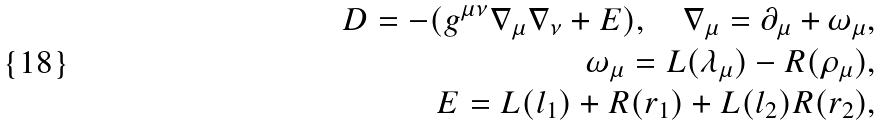Convert formula to latex. <formula><loc_0><loc_0><loc_500><loc_500>D = - ( g ^ { \mu \nu } \nabla _ { \mu } \nabla _ { \nu } + E ) , \quad \nabla _ { \mu } = \partial _ { \mu } + \omega _ { \mu } , \\ \omega _ { \mu } = L ( \lambda _ { \mu } ) - R ( \rho _ { \mu } ) , \\ E = L ( l _ { 1 } ) + R ( r _ { 1 } ) + L ( l _ { 2 } ) R ( r _ { 2 } ) ,</formula> 